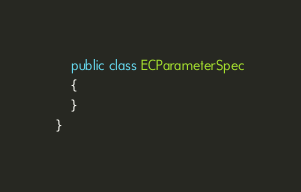Convert code to text. <code><loc_0><loc_0><loc_500><loc_500><_C#_>	public class ECParameterSpec
	{
	}
}
</code> 